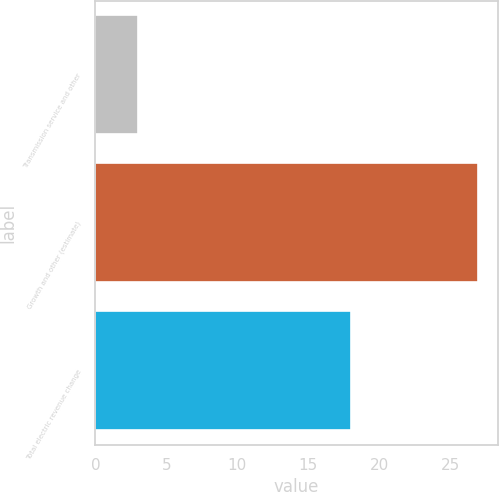Convert chart to OTSL. <chart><loc_0><loc_0><loc_500><loc_500><bar_chart><fcel>Transmission service and other<fcel>Growth and other (estimate)<fcel>Total electric revenue change<nl><fcel>3<fcel>27<fcel>18<nl></chart> 